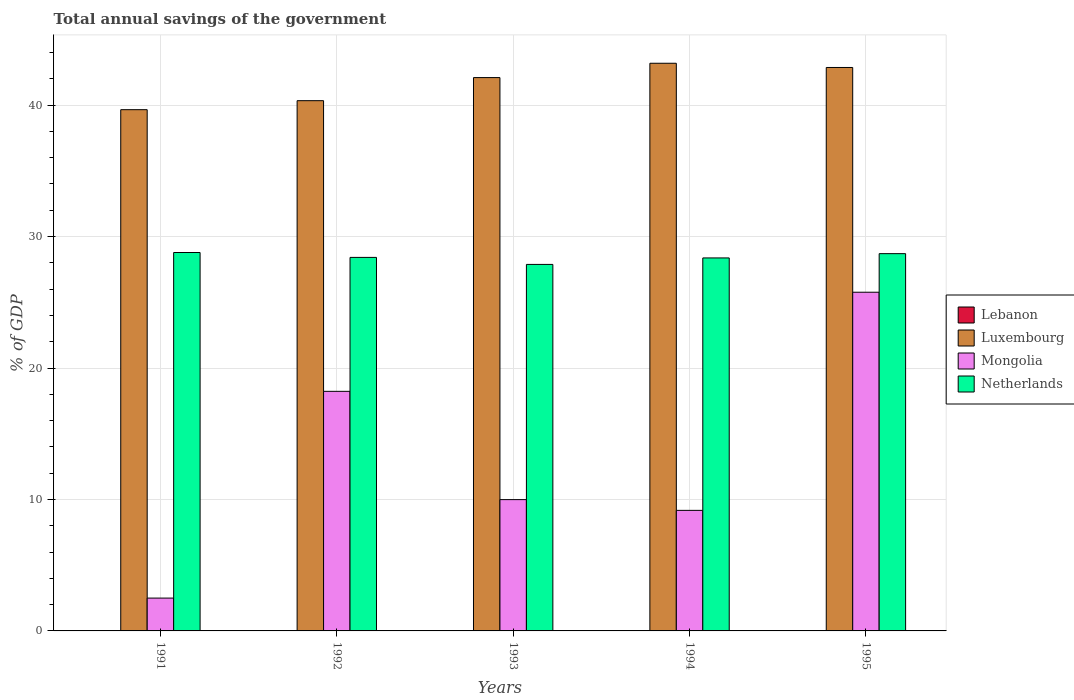How many different coloured bars are there?
Make the answer very short. 3. Are the number of bars per tick equal to the number of legend labels?
Your answer should be compact. No. Are the number of bars on each tick of the X-axis equal?
Provide a short and direct response. Yes. How many bars are there on the 3rd tick from the left?
Give a very brief answer. 3. How many bars are there on the 4th tick from the right?
Offer a very short reply. 3. What is the label of the 3rd group of bars from the left?
Offer a very short reply. 1993. What is the total annual savings of the government in Lebanon in 1993?
Offer a very short reply. 0. Across all years, what is the maximum total annual savings of the government in Luxembourg?
Your answer should be very brief. 43.18. Across all years, what is the minimum total annual savings of the government in Lebanon?
Keep it short and to the point. 0. What is the total total annual savings of the government in Luxembourg in the graph?
Your answer should be very brief. 208.12. What is the difference between the total annual savings of the government in Luxembourg in 1992 and that in 1994?
Ensure brevity in your answer.  -2.85. What is the difference between the total annual savings of the government in Netherlands in 1991 and the total annual savings of the government in Mongolia in 1995?
Keep it short and to the point. 3.02. In the year 1991, what is the difference between the total annual savings of the government in Mongolia and total annual savings of the government in Luxembourg?
Offer a terse response. -37.15. What is the ratio of the total annual savings of the government in Luxembourg in 1992 to that in 1994?
Make the answer very short. 0.93. Is the difference between the total annual savings of the government in Mongolia in 1992 and 1993 greater than the difference between the total annual savings of the government in Luxembourg in 1992 and 1993?
Ensure brevity in your answer.  Yes. What is the difference between the highest and the second highest total annual savings of the government in Mongolia?
Offer a very short reply. 7.54. What is the difference between the highest and the lowest total annual savings of the government in Luxembourg?
Ensure brevity in your answer.  3.53. Is it the case that in every year, the sum of the total annual savings of the government in Netherlands and total annual savings of the government in Mongolia is greater than the total annual savings of the government in Luxembourg?
Your answer should be compact. No. How many bars are there?
Your answer should be compact. 15. Are all the bars in the graph horizontal?
Your answer should be compact. No. How many years are there in the graph?
Ensure brevity in your answer.  5. What is the difference between two consecutive major ticks on the Y-axis?
Give a very brief answer. 10. Does the graph contain any zero values?
Ensure brevity in your answer.  Yes. Where does the legend appear in the graph?
Ensure brevity in your answer.  Center right. How many legend labels are there?
Your answer should be very brief. 4. How are the legend labels stacked?
Provide a short and direct response. Vertical. What is the title of the graph?
Offer a terse response. Total annual savings of the government. Does "Algeria" appear as one of the legend labels in the graph?
Your response must be concise. No. What is the label or title of the X-axis?
Your answer should be very brief. Years. What is the label or title of the Y-axis?
Offer a terse response. % of GDP. What is the % of GDP in Luxembourg in 1991?
Make the answer very short. 39.65. What is the % of GDP of Mongolia in 1991?
Offer a very short reply. 2.5. What is the % of GDP of Netherlands in 1991?
Offer a terse response. 28.79. What is the % of GDP of Luxembourg in 1992?
Your response must be concise. 40.33. What is the % of GDP of Mongolia in 1992?
Provide a short and direct response. 18.23. What is the % of GDP in Netherlands in 1992?
Offer a very short reply. 28.41. What is the % of GDP in Lebanon in 1993?
Offer a terse response. 0. What is the % of GDP in Luxembourg in 1993?
Your response must be concise. 42.09. What is the % of GDP of Mongolia in 1993?
Your response must be concise. 9.99. What is the % of GDP in Netherlands in 1993?
Offer a terse response. 27.88. What is the % of GDP of Lebanon in 1994?
Make the answer very short. 0. What is the % of GDP in Luxembourg in 1994?
Provide a succinct answer. 43.18. What is the % of GDP in Mongolia in 1994?
Make the answer very short. 9.17. What is the % of GDP of Netherlands in 1994?
Give a very brief answer. 28.37. What is the % of GDP of Luxembourg in 1995?
Provide a short and direct response. 42.86. What is the % of GDP in Mongolia in 1995?
Your answer should be compact. 25.76. What is the % of GDP in Netherlands in 1995?
Provide a succinct answer. 28.7. Across all years, what is the maximum % of GDP of Luxembourg?
Offer a terse response. 43.18. Across all years, what is the maximum % of GDP of Mongolia?
Your response must be concise. 25.76. Across all years, what is the maximum % of GDP in Netherlands?
Your answer should be very brief. 28.79. Across all years, what is the minimum % of GDP in Luxembourg?
Make the answer very short. 39.65. Across all years, what is the minimum % of GDP of Mongolia?
Offer a terse response. 2.5. Across all years, what is the minimum % of GDP in Netherlands?
Your answer should be compact. 27.88. What is the total % of GDP in Lebanon in the graph?
Your answer should be very brief. 0. What is the total % of GDP of Luxembourg in the graph?
Keep it short and to the point. 208.12. What is the total % of GDP of Mongolia in the graph?
Offer a very short reply. 65.65. What is the total % of GDP of Netherlands in the graph?
Ensure brevity in your answer.  142.15. What is the difference between the % of GDP of Luxembourg in 1991 and that in 1992?
Give a very brief answer. -0.68. What is the difference between the % of GDP of Mongolia in 1991 and that in 1992?
Your answer should be compact. -15.73. What is the difference between the % of GDP of Netherlands in 1991 and that in 1992?
Your answer should be very brief. 0.37. What is the difference between the % of GDP of Luxembourg in 1991 and that in 1993?
Provide a short and direct response. -2.44. What is the difference between the % of GDP in Mongolia in 1991 and that in 1993?
Offer a very short reply. -7.49. What is the difference between the % of GDP in Netherlands in 1991 and that in 1993?
Your response must be concise. 0.91. What is the difference between the % of GDP in Luxembourg in 1991 and that in 1994?
Offer a very short reply. -3.53. What is the difference between the % of GDP in Mongolia in 1991 and that in 1994?
Your answer should be very brief. -6.67. What is the difference between the % of GDP in Netherlands in 1991 and that in 1994?
Provide a succinct answer. 0.41. What is the difference between the % of GDP in Luxembourg in 1991 and that in 1995?
Keep it short and to the point. -3.21. What is the difference between the % of GDP in Mongolia in 1991 and that in 1995?
Ensure brevity in your answer.  -23.27. What is the difference between the % of GDP in Netherlands in 1991 and that in 1995?
Your answer should be compact. 0.09. What is the difference between the % of GDP of Luxembourg in 1992 and that in 1993?
Offer a very short reply. -1.76. What is the difference between the % of GDP of Mongolia in 1992 and that in 1993?
Provide a short and direct response. 8.24. What is the difference between the % of GDP of Netherlands in 1992 and that in 1993?
Your answer should be very brief. 0.53. What is the difference between the % of GDP in Luxembourg in 1992 and that in 1994?
Ensure brevity in your answer.  -2.85. What is the difference between the % of GDP in Mongolia in 1992 and that in 1994?
Offer a very short reply. 9.05. What is the difference between the % of GDP of Netherlands in 1992 and that in 1994?
Provide a succinct answer. 0.04. What is the difference between the % of GDP of Luxembourg in 1992 and that in 1995?
Make the answer very short. -2.53. What is the difference between the % of GDP of Mongolia in 1992 and that in 1995?
Provide a short and direct response. -7.54. What is the difference between the % of GDP of Netherlands in 1992 and that in 1995?
Make the answer very short. -0.29. What is the difference between the % of GDP in Luxembourg in 1993 and that in 1994?
Offer a very short reply. -1.09. What is the difference between the % of GDP in Mongolia in 1993 and that in 1994?
Your answer should be compact. 0.82. What is the difference between the % of GDP of Netherlands in 1993 and that in 1994?
Your response must be concise. -0.49. What is the difference between the % of GDP of Luxembourg in 1993 and that in 1995?
Make the answer very short. -0.77. What is the difference between the % of GDP of Mongolia in 1993 and that in 1995?
Offer a terse response. -15.78. What is the difference between the % of GDP of Netherlands in 1993 and that in 1995?
Give a very brief answer. -0.82. What is the difference between the % of GDP in Luxembourg in 1994 and that in 1995?
Provide a short and direct response. 0.32. What is the difference between the % of GDP in Mongolia in 1994 and that in 1995?
Keep it short and to the point. -16.59. What is the difference between the % of GDP in Netherlands in 1994 and that in 1995?
Your answer should be compact. -0.33. What is the difference between the % of GDP of Luxembourg in 1991 and the % of GDP of Mongolia in 1992?
Keep it short and to the point. 21.43. What is the difference between the % of GDP of Luxembourg in 1991 and the % of GDP of Netherlands in 1992?
Keep it short and to the point. 11.24. What is the difference between the % of GDP of Mongolia in 1991 and the % of GDP of Netherlands in 1992?
Ensure brevity in your answer.  -25.92. What is the difference between the % of GDP in Luxembourg in 1991 and the % of GDP in Mongolia in 1993?
Provide a short and direct response. 29.66. What is the difference between the % of GDP of Luxembourg in 1991 and the % of GDP of Netherlands in 1993?
Provide a succinct answer. 11.77. What is the difference between the % of GDP in Mongolia in 1991 and the % of GDP in Netherlands in 1993?
Provide a short and direct response. -25.38. What is the difference between the % of GDP in Luxembourg in 1991 and the % of GDP in Mongolia in 1994?
Offer a very short reply. 30.48. What is the difference between the % of GDP in Luxembourg in 1991 and the % of GDP in Netherlands in 1994?
Your answer should be very brief. 11.28. What is the difference between the % of GDP in Mongolia in 1991 and the % of GDP in Netherlands in 1994?
Your answer should be compact. -25.88. What is the difference between the % of GDP of Luxembourg in 1991 and the % of GDP of Mongolia in 1995?
Your answer should be very brief. 13.89. What is the difference between the % of GDP of Luxembourg in 1991 and the % of GDP of Netherlands in 1995?
Your response must be concise. 10.95. What is the difference between the % of GDP in Mongolia in 1991 and the % of GDP in Netherlands in 1995?
Offer a terse response. -26.2. What is the difference between the % of GDP in Luxembourg in 1992 and the % of GDP in Mongolia in 1993?
Your answer should be compact. 30.35. What is the difference between the % of GDP in Luxembourg in 1992 and the % of GDP in Netherlands in 1993?
Your answer should be compact. 12.46. What is the difference between the % of GDP in Mongolia in 1992 and the % of GDP in Netherlands in 1993?
Offer a terse response. -9.65. What is the difference between the % of GDP in Luxembourg in 1992 and the % of GDP in Mongolia in 1994?
Offer a terse response. 31.16. What is the difference between the % of GDP of Luxembourg in 1992 and the % of GDP of Netherlands in 1994?
Your answer should be very brief. 11.96. What is the difference between the % of GDP in Mongolia in 1992 and the % of GDP in Netherlands in 1994?
Provide a short and direct response. -10.15. What is the difference between the % of GDP of Luxembourg in 1992 and the % of GDP of Mongolia in 1995?
Your answer should be very brief. 14.57. What is the difference between the % of GDP of Luxembourg in 1992 and the % of GDP of Netherlands in 1995?
Offer a very short reply. 11.64. What is the difference between the % of GDP of Mongolia in 1992 and the % of GDP of Netherlands in 1995?
Ensure brevity in your answer.  -10.47. What is the difference between the % of GDP of Luxembourg in 1993 and the % of GDP of Mongolia in 1994?
Your answer should be very brief. 32.92. What is the difference between the % of GDP of Luxembourg in 1993 and the % of GDP of Netherlands in 1994?
Your answer should be very brief. 13.72. What is the difference between the % of GDP of Mongolia in 1993 and the % of GDP of Netherlands in 1994?
Your answer should be compact. -18.38. What is the difference between the % of GDP in Luxembourg in 1993 and the % of GDP in Mongolia in 1995?
Keep it short and to the point. 16.33. What is the difference between the % of GDP of Luxembourg in 1993 and the % of GDP of Netherlands in 1995?
Ensure brevity in your answer.  13.39. What is the difference between the % of GDP in Mongolia in 1993 and the % of GDP in Netherlands in 1995?
Offer a terse response. -18.71. What is the difference between the % of GDP of Luxembourg in 1994 and the % of GDP of Mongolia in 1995?
Your answer should be very brief. 17.42. What is the difference between the % of GDP in Luxembourg in 1994 and the % of GDP in Netherlands in 1995?
Offer a terse response. 14.48. What is the difference between the % of GDP in Mongolia in 1994 and the % of GDP in Netherlands in 1995?
Offer a very short reply. -19.53. What is the average % of GDP in Lebanon per year?
Your answer should be very brief. 0. What is the average % of GDP of Luxembourg per year?
Keep it short and to the point. 41.62. What is the average % of GDP in Mongolia per year?
Make the answer very short. 13.13. What is the average % of GDP of Netherlands per year?
Offer a very short reply. 28.43. In the year 1991, what is the difference between the % of GDP in Luxembourg and % of GDP in Mongolia?
Give a very brief answer. 37.15. In the year 1991, what is the difference between the % of GDP in Luxembourg and % of GDP in Netherlands?
Your response must be concise. 10.86. In the year 1991, what is the difference between the % of GDP in Mongolia and % of GDP in Netherlands?
Provide a succinct answer. -26.29. In the year 1992, what is the difference between the % of GDP of Luxembourg and % of GDP of Mongolia?
Give a very brief answer. 22.11. In the year 1992, what is the difference between the % of GDP of Luxembourg and % of GDP of Netherlands?
Ensure brevity in your answer.  11.92. In the year 1992, what is the difference between the % of GDP in Mongolia and % of GDP in Netherlands?
Give a very brief answer. -10.19. In the year 1993, what is the difference between the % of GDP in Luxembourg and % of GDP in Mongolia?
Provide a short and direct response. 32.1. In the year 1993, what is the difference between the % of GDP of Luxembourg and % of GDP of Netherlands?
Ensure brevity in your answer.  14.21. In the year 1993, what is the difference between the % of GDP in Mongolia and % of GDP in Netherlands?
Offer a terse response. -17.89. In the year 1994, what is the difference between the % of GDP of Luxembourg and % of GDP of Mongolia?
Keep it short and to the point. 34.01. In the year 1994, what is the difference between the % of GDP of Luxembourg and % of GDP of Netherlands?
Give a very brief answer. 14.81. In the year 1994, what is the difference between the % of GDP of Mongolia and % of GDP of Netherlands?
Offer a terse response. -19.2. In the year 1995, what is the difference between the % of GDP in Luxembourg and % of GDP in Mongolia?
Provide a short and direct response. 17.1. In the year 1995, what is the difference between the % of GDP in Luxembourg and % of GDP in Netherlands?
Provide a short and direct response. 14.16. In the year 1995, what is the difference between the % of GDP in Mongolia and % of GDP in Netherlands?
Make the answer very short. -2.93. What is the ratio of the % of GDP of Luxembourg in 1991 to that in 1992?
Ensure brevity in your answer.  0.98. What is the ratio of the % of GDP in Mongolia in 1991 to that in 1992?
Your answer should be very brief. 0.14. What is the ratio of the % of GDP of Netherlands in 1991 to that in 1992?
Give a very brief answer. 1.01. What is the ratio of the % of GDP in Luxembourg in 1991 to that in 1993?
Make the answer very short. 0.94. What is the ratio of the % of GDP of Mongolia in 1991 to that in 1993?
Your answer should be very brief. 0.25. What is the ratio of the % of GDP of Netherlands in 1991 to that in 1993?
Keep it short and to the point. 1.03. What is the ratio of the % of GDP in Luxembourg in 1991 to that in 1994?
Provide a succinct answer. 0.92. What is the ratio of the % of GDP in Mongolia in 1991 to that in 1994?
Offer a terse response. 0.27. What is the ratio of the % of GDP in Netherlands in 1991 to that in 1994?
Provide a short and direct response. 1.01. What is the ratio of the % of GDP of Luxembourg in 1991 to that in 1995?
Provide a short and direct response. 0.93. What is the ratio of the % of GDP of Mongolia in 1991 to that in 1995?
Offer a very short reply. 0.1. What is the ratio of the % of GDP of Netherlands in 1991 to that in 1995?
Keep it short and to the point. 1. What is the ratio of the % of GDP in Mongolia in 1992 to that in 1993?
Provide a succinct answer. 1.82. What is the ratio of the % of GDP in Netherlands in 1992 to that in 1993?
Provide a short and direct response. 1.02. What is the ratio of the % of GDP in Luxembourg in 1992 to that in 1994?
Give a very brief answer. 0.93. What is the ratio of the % of GDP in Mongolia in 1992 to that in 1994?
Offer a terse response. 1.99. What is the ratio of the % of GDP in Luxembourg in 1992 to that in 1995?
Provide a short and direct response. 0.94. What is the ratio of the % of GDP in Mongolia in 1992 to that in 1995?
Give a very brief answer. 0.71. What is the ratio of the % of GDP of Netherlands in 1992 to that in 1995?
Ensure brevity in your answer.  0.99. What is the ratio of the % of GDP in Luxembourg in 1993 to that in 1994?
Your answer should be compact. 0.97. What is the ratio of the % of GDP of Mongolia in 1993 to that in 1994?
Give a very brief answer. 1.09. What is the ratio of the % of GDP in Netherlands in 1993 to that in 1994?
Provide a short and direct response. 0.98. What is the ratio of the % of GDP of Luxembourg in 1993 to that in 1995?
Make the answer very short. 0.98. What is the ratio of the % of GDP of Mongolia in 1993 to that in 1995?
Your answer should be compact. 0.39. What is the ratio of the % of GDP in Netherlands in 1993 to that in 1995?
Keep it short and to the point. 0.97. What is the ratio of the % of GDP in Luxembourg in 1994 to that in 1995?
Your answer should be very brief. 1.01. What is the ratio of the % of GDP in Mongolia in 1994 to that in 1995?
Your response must be concise. 0.36. What is the difference between the highest and the second highest % of GDP in Luxembourg?
Your answer should be very brief. 0.32. What is the difference between the highest and the second highest % of GDP of Mongolia?
Offer a very short reply. 7.54. What is the difference between the highest and the second highest % of GDP in Netherlands?
Provide a succinct answer. 0.09. What is the difference between the highest and the lowest % of GDP in Luxembourg?
Give a very brief answer. 3.53. What is the difference between the highest and the lowest % of GDP of Mongolia?
Your answer should be very brief. 23.27. What is the difference between the highest and the lowest % of GDP in Netherlands?
Offer a terse response. 0.91. 